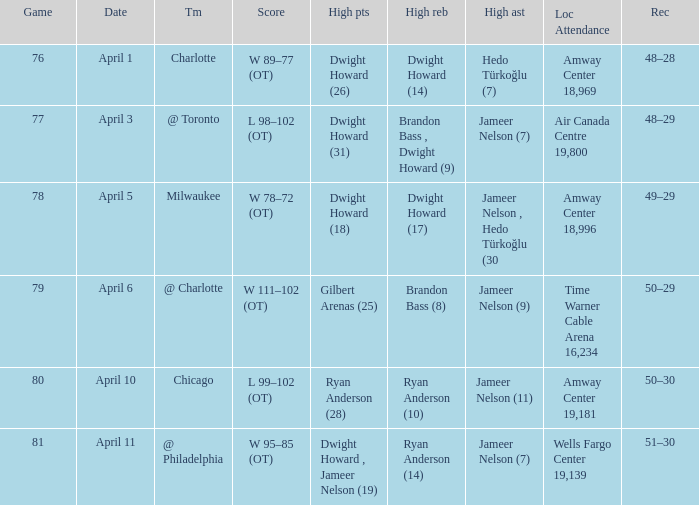What was the venue and the number of attendees for the game on april 3? Air Canada Centre 19,800. 